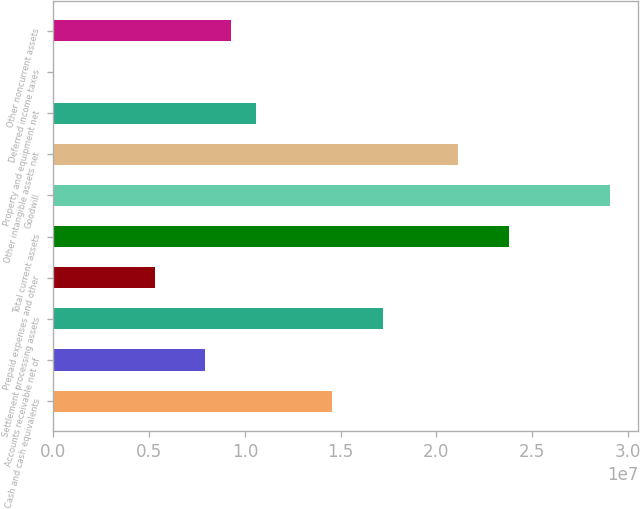<chart> <loc_0><loc_0><loc_500><loc_500><bar_chart><fcel>Cash and cash equivalents<fcel>Accounts receivable net of<fcel>Settlement processing assets<fcel>Prepaid expenses and other<fcel>Total current assets<fcel>Goodwill<fcel>Other intangible assets net<fcel>Property and equipment net<fcel>Deferred income taxes<fcel>Other noncurrent assets<nl><fcel>1.4553e+07<fcel>7.94172e+06<fcel>1.71976e+07<fcel>5.29719e+06<fcel>2.38089e+07<fcel>2.90979e+07<fcel>2.11644e+07<fcel>1.05862e+07<fcel>8128<fcel>9.26398e+06<nl></chart> 